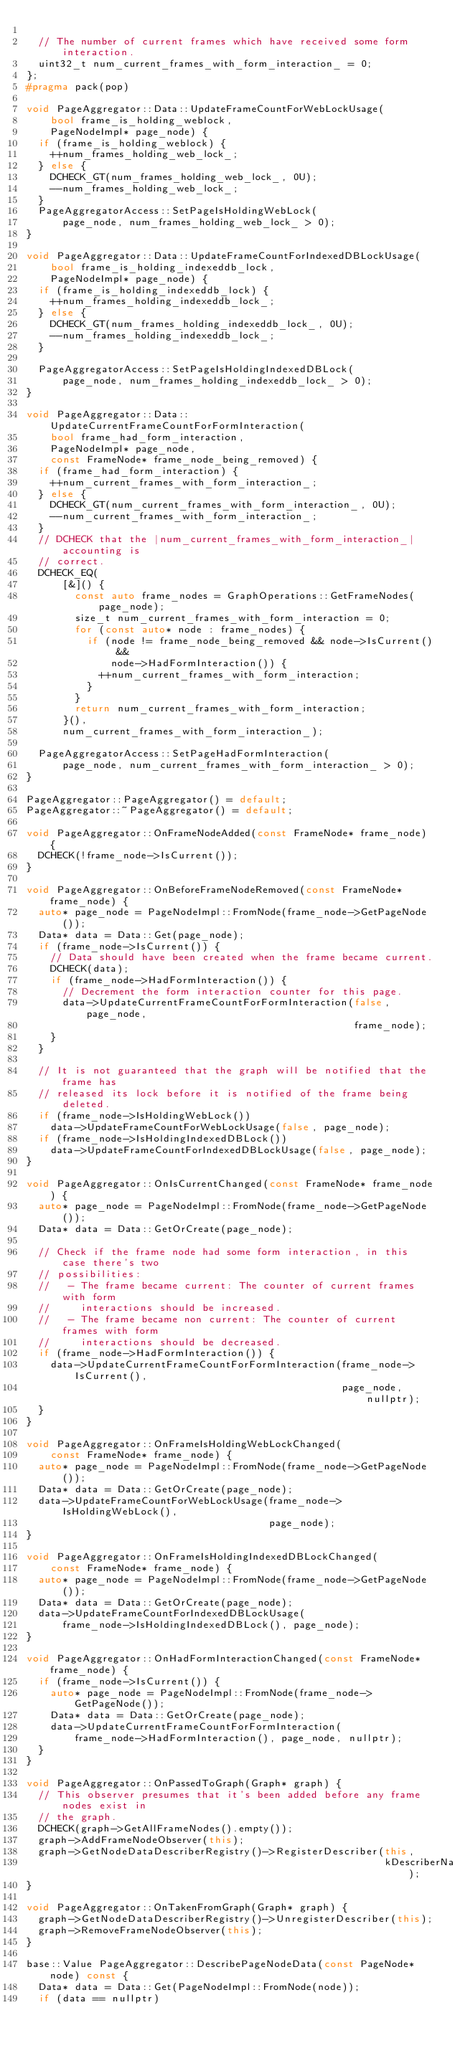Convert code to text. <code><loc_0><loc_0><loc_500><loc_500><_C++_>
  // The number of current frames which have received some form interaction.
  uint32_t num_current_frames_with_form_interaction_ = 0;
};
#pragma pack(pop)

void PageAggregator::Data::UpdateFrameCountForWebLockUsage(
    bool frame_is_holding_weblock,
    PageNodeImpl* page_node) {
  if (frame_is_holding_weblock) {
    ++num_frames_holding_web_lock_;
  } else {
    DCHECK_GT(num_frames_holding_web_lock_, 0U);
    --num_frames_holding_web_lock_;
  }
  PageAggregatorAccess::SetPageIsHoldingWebLock(
      page_node, num_frames_holding_web_lock_ > 0);
}

void PageAggregator::Data::UpdateFrameCountForIndexedDBLockUsage(
    bool frame_is_holding_indexeddb_lock,
    PageNodeImpl* page_node) {
  if (frame_is_holding_indexeddb_lock) {
    ++num_frames_holding_indexeddb_lock_;
  } else {
    DCHECK_GT(num_frames_holding_indexeddb_lock_, 0U);
    --num_frames_holding_indexeddb_lock_;
  }

  PageAggregatorAccess::SetPageIsHoldingIndexedDBLock(
      page_node, num_frames_holding_indexeddb_lock_ > 0);
}

void PageAggregator::Data::UpdateCurrentFrameCountForFormInteraction(
    bool frame_had_form_interaction,
    PageNodeImpl* page_node,
    const FrameNode* frame_node_being_removed) {
  if (frame_had_form_interaction) {
    ++num_current_frames_with_form_interaction_;
  } else {
    DCHECK_GT(num_current_frames_with_form_interaction_, 0U);
    --num_current_frames_with_form_interaction_;
  }
  // DCHECK that the |num_current_frames_with_form_interaction_| accounting is
  // correct.
  DCHECK_EQ(
      [&]() {
        const auto frame_nodes = GraphOperations::GetFrameNodes(page_node);
        size_t num_current_frames_with_form_interaction = 0;
        for (const auto* node : frame_nodes) {
          if (node != frame_node_being_removed && node->IsCurrent() &&
              node->HadFormInteraction()) {
            ++num_current_frames_with_form_interaction;
          }
        }
        return num_current_frames_with_form_interaction;
      }(),
      num_current_frames_with_form_interaction_);

  PageAggregatorAccess::SetPageHadFormInteraction(
      page_node, num_current_frames_with_form_interaction_ > 0);
}

PageAggregator::PageAggregator() = default;
PageAggregator::~PageAggregator() = default;

void PageAggregator::OnFrameNodeAdded(const FrameNode* frame_node) {
  DCHECK(!frame_node->IsCurrent());
}

void PageAggregator::OnBeforeFrameNodeRemoved(const FrameNode* frame_node) {
  auto* page_node = PageNodeImpl::FromNode(frame_node->GetPageNode());
  Data* data = Data::Get(page_node);
  if (frame_node->IsCurrent()) {
    // Data should have been created when the frame became current.
    DCHECK(data);
    if (frame_node->HadFormInteraction()) {
      // Decrement the form interaction counter for this page.
      data->UpdateCurrentFrameCountForFormInteraction(false, page_node,
                                                      frame_node);
    }
  }

  // It is not guaranteed that the graph will be notified that the frame has
  // released its lock before it is notified of the frame being deleted.
  if (frame_node->IsHoldingWebLock())
    data->UpdateFrameCountForWebLockUsage(false, page_node);
  if (frame_node->IsHoldingIndexedDBLock())
    data->UpdateFrameCountForIndexedDBLockUsage(false, page_node);
}

void PageAggregator::OnIsCurrentChanged(const FrameNode* frame_node) {
  auto* page_node = PageNodeImpl::FromNode(frame_node->GetPageNode());
  Data* data = Data::GetOrCreate(page_node);

  // Check if the frame node had some form interaction, in this case there's two
  // possibilities:
  //   - The frame became current: The counter of current frames with form
  //     interactions should be increased.
  //   - The frame became non current: The counter of current frames with form
  //     interactions should be decreased.
  if (frame_node->HadFormInteraction()) {
    data->UpdateCurrentFrameCountForFormInteraction(frame_node->IsCurrent(),
                                                    page_node, nullptr);
  }
}

void PageAggregator::OnFrameIsHoldingWebLockChanged(
    const FrameNode* frame_node) {
  auto* page_node = PageNodeImpl::FromNode(frame_node->GetPageNode());
  Data* data = Data::GetOrCreate(page_node);
  data->UpdateFrameCountForWebLockUsage(frame_node->IsHoldingWebLock(),
                                        page_node);
}

void PageAggregator::OnFrameIsHoldingIndexedDBLockChanged(
    const FrameNode* frame_node) {
  auto* page_node = PageNodeImpl::FromNode(frame_node->GetPageNode());
  Data* data = Data::GetOrCreate(page_node);
  data->UpdateFrameCountForIndexedDBLockUsage(
      frame_node->IsHoldingIndexedDBLock(), page_node);
}

void PageAggregator::OnHadFormInteractionChanged(const FrameNode* frame_node) {
  if (frame_node->IsCurrent()) {
    auto* page_node = PageNodeImpl::FromNode(frame_node->GetPageNode());
    Data* data = Data::GetOrCreate(page_node);
    data->UpdateCurrentFrameCountForFormInteraction(
        frame_node->HadFormInteraction(), page_node, nullptr);
  }
}

void PageAggregator::OnPassedToGraph(Graph* graph) {
  // This observer presumes that it's been added before any frame nodes exist in
  // the graph.
  DCHECK(graph->GetAllFrameNodes().empty());
  graph->AddFrameNodeObserver(this);
  graph->GetNodeDataDescriberRegistry()->RegisterDescriber(this,
                                                           kDescriberName);
}

void PageAggregator::OnTakenFromGraph(Graph* graph) {
  graph->GetNodeDataDescriberRegistry()->UnregisterDescriber(this);
  graph->RemoveFrameNodeObserver(this);
}

base::Value PageAggregator::DescribePageNodeData(const PageNode* node) const {
  Data* data = Data::Get(PageNodeImpl::FromNode(node));
  if (data == nullptr)</code> 